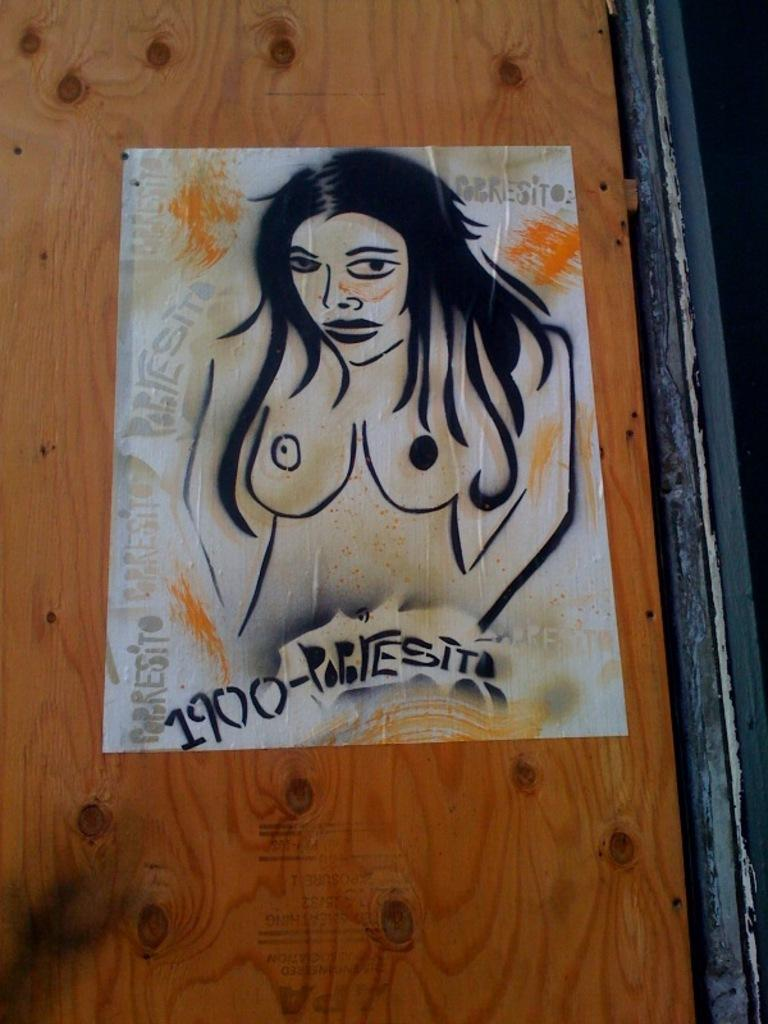What is the color of the wooden surface in the image? The wooden surface in the image is brown colored. What is placed on the wooden surface? There is a paper on the wooden surface. What is depicted on the paper? The paper contains a painting of a woman. What color is used to depict the woman in the painting? The woman in the painting is depicted with black color. Can you tell me where the library is located in the image? There is no library present in the image. What type of spade is being used by the woman in the painting? The painting does not depict the woman using a spade; it only shows her as a subject. 